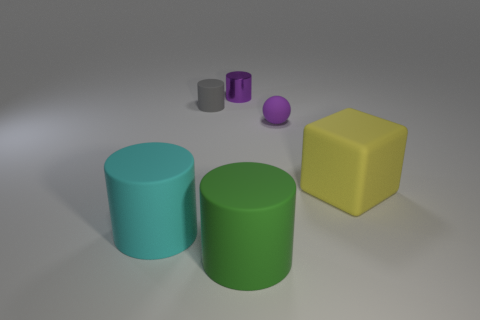Add 2 purple spheres. How many objects exist? 8 Subtract all balls. How many objects are left? 5 Add 1 yellow metal cylinders. How many yellow metal cylinders exist? 1 Subtract 0 brown cylinders. How many objects are left? 6 Subtract all small matte things. Subtract all small purple matte balls. How many objects are left? 3 Add 6 blocks. How many blocks are left? 7 